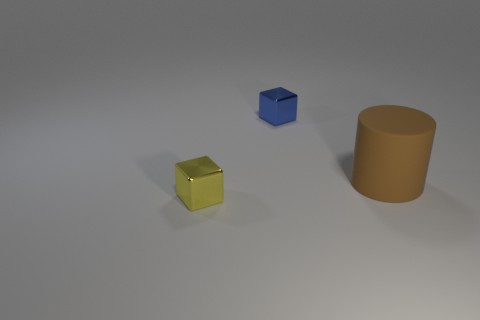Add 1 blue cubes. How many objects exist? 4 Subtract 0 yellow cylinders. How many objects are left? 3 Subtract all blocks. How many objects are left? 1 Subtract all cyan cylinders. Subtract all brown blocks. How many cylinders are left? 1 Subtract all tiny blue rubber spheres. Subtract all matte cylinders. How many objects are left? 2 Add 1 big matte things. How many big matte things are left? 2 Add 3 matte things. How many matte things exist? 4 